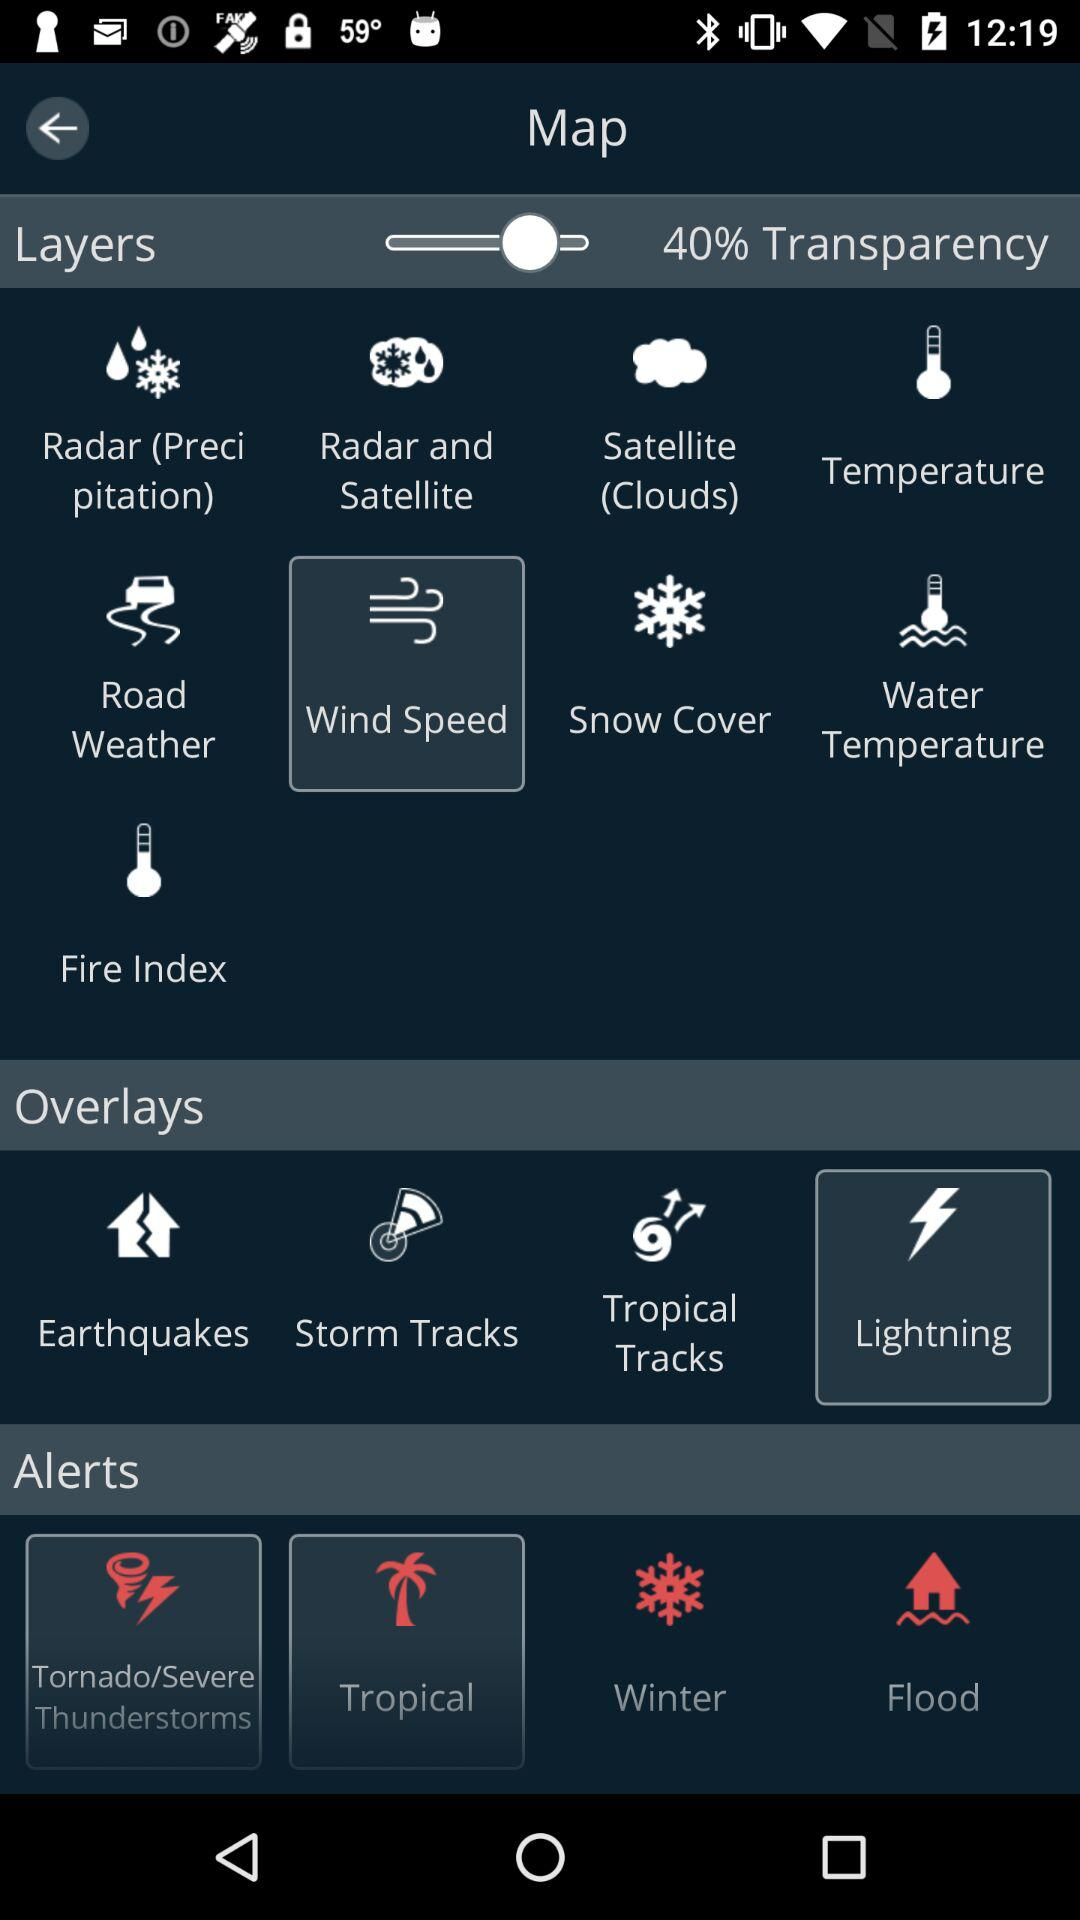What is the transparency of layers? The transparency of layers is 40%. 